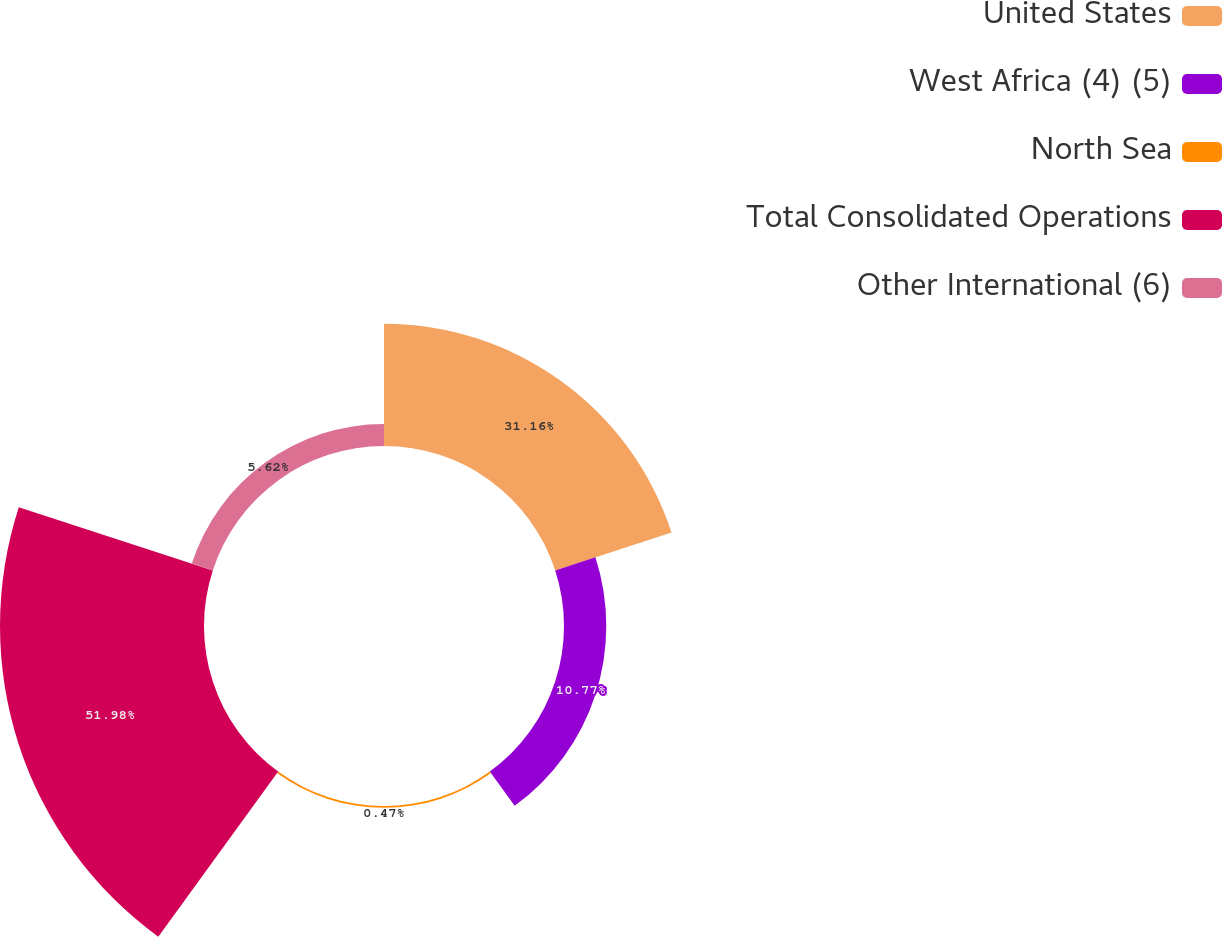Convert chart. <chart><loc_0><loc_0><loc_500><loc_500><pie_chart><fcel>United States<fcel>West Africa (4) (5)<fcel>North Sea<fcel>Total Consolidated Operations<fcel>Other International (6)<nl><fcel>31.16%<fcel>10.77%<fcel>0.47%<fcel>51.97%<fcel>5.62%<nl></chart> 